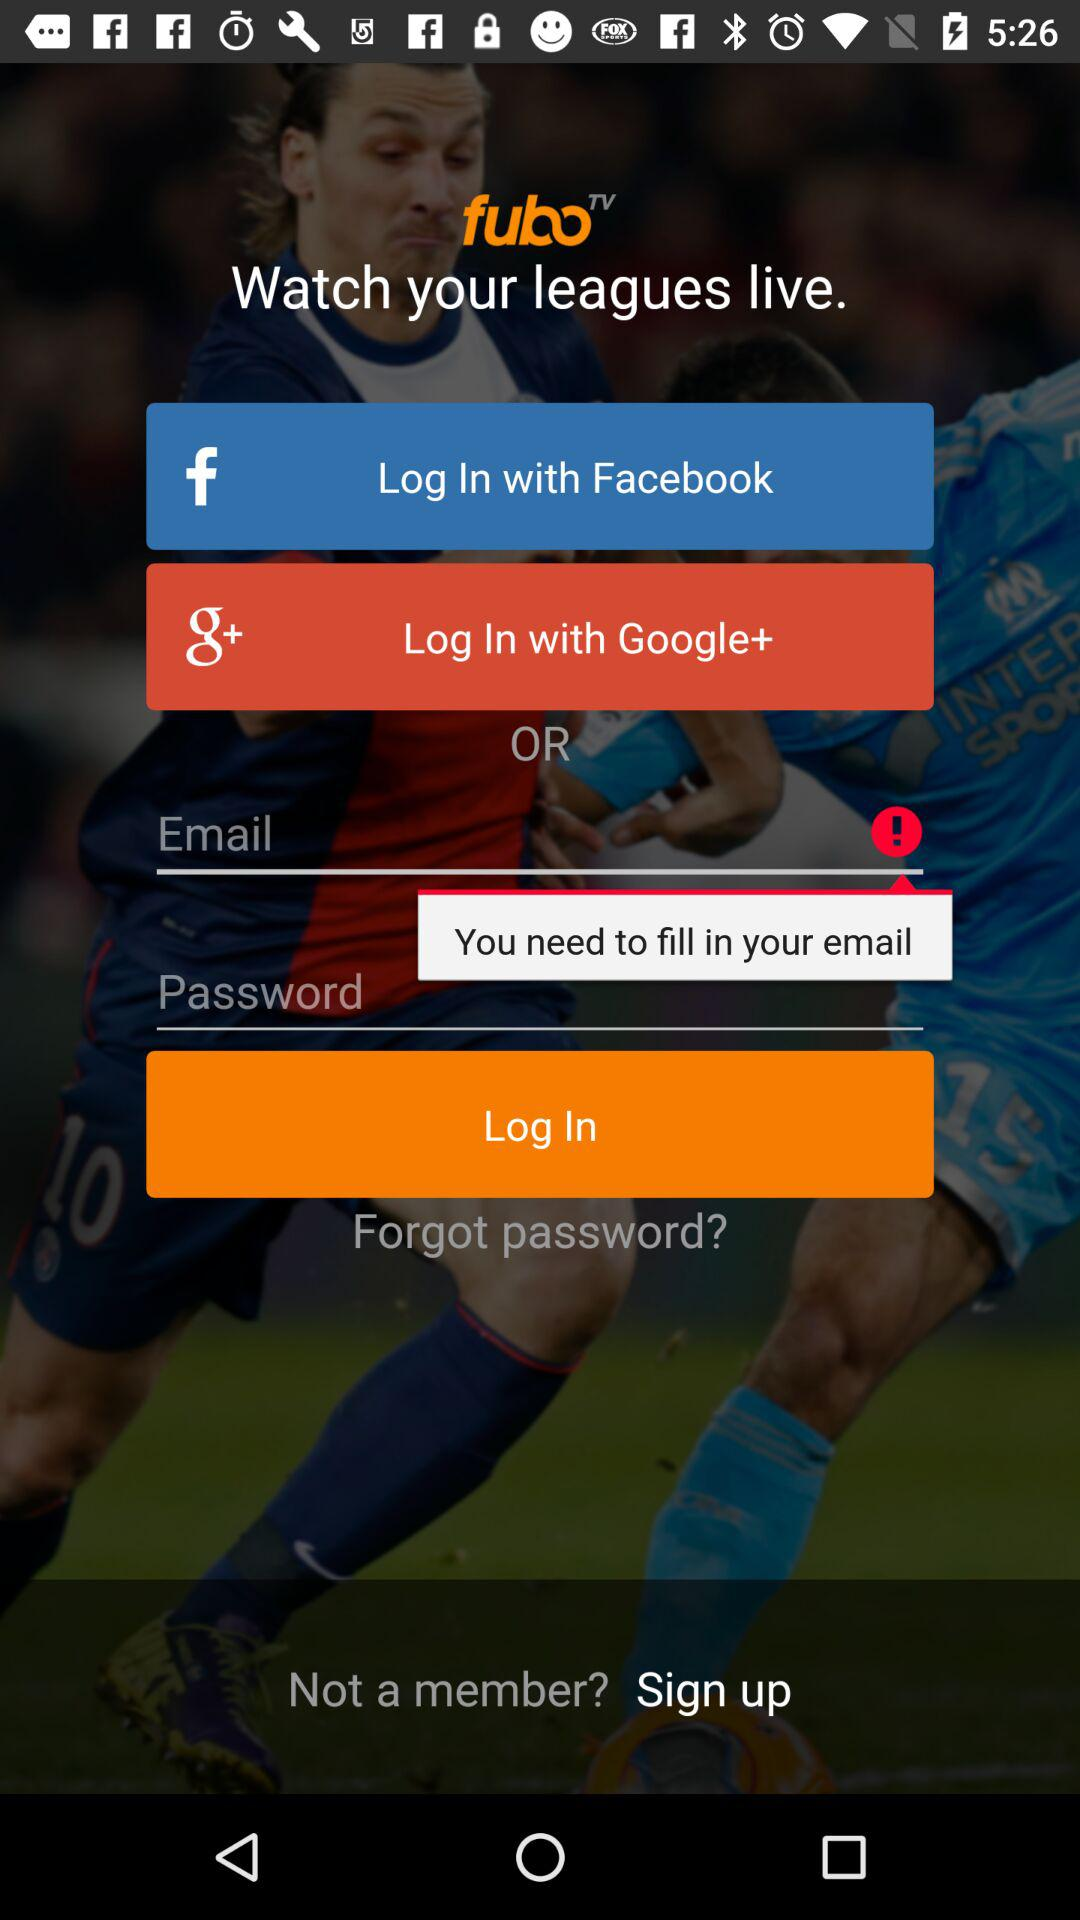What are the different options available for login? The different options available for login are "Facebook" and "Google+". 